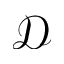<formula> <loc_0><loc_0><loc_500><loc_500>\mathcal { D }</formula> 